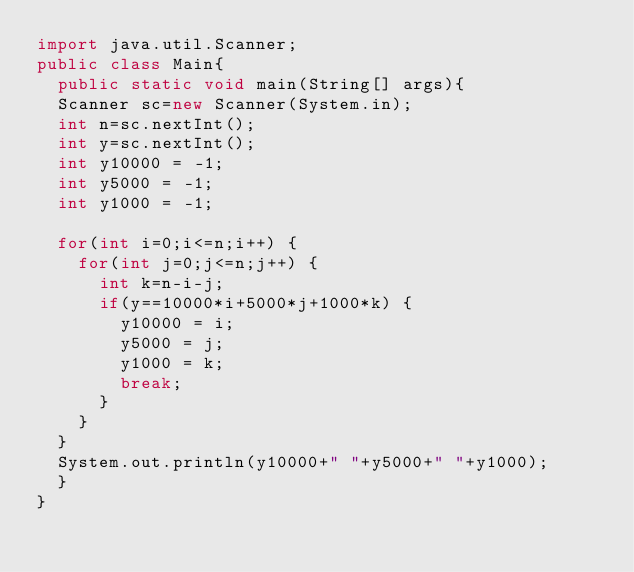Convert code to text. <code><loc_0><loc_0><loc_500><loc_500><_Java_>import java.util.Scanner;
public class Main{
	public static void main(String[] args){
	Scanner sc=new Scanner(System.in);
	int n=sc.nextInt();
	int y=sc.nextInt();
	int y10000 = -1;
	int y5000 = -1;
	int y1000 = -1;

	for(int i=0;i<=n;i++) {
		for(int j=0;j<=n;j++) {
			int k=n-i-j;
			if(y==10000*i+5000*j+1000*k) {
				y10000 = i;
				y5000 = j;
				y1000 = k;
				break;
			}
		}
	}
	System.out.println(y10000+" "+y5000+" "+y1000);
	}
}</code> 